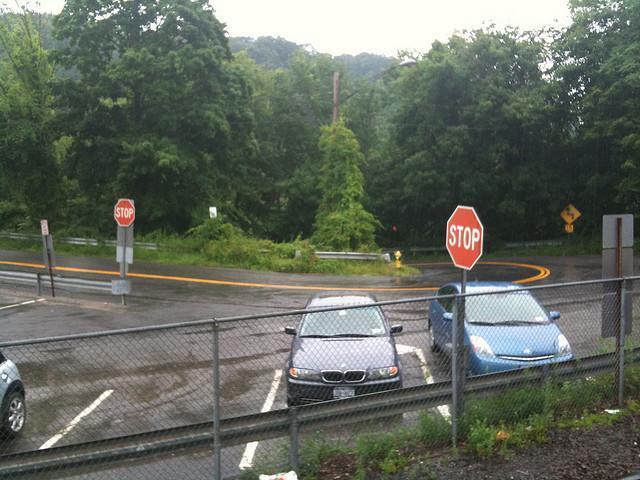How many cars are there?
Give a very brief answer. 2. 